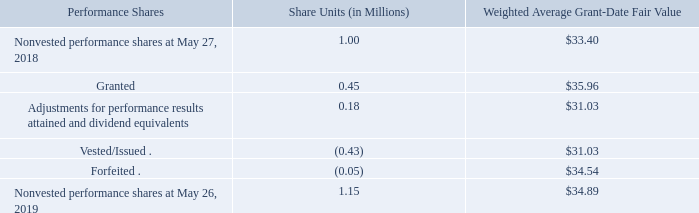Performance Share Awards
In accordance with stockholder-approved equity incentive plans, we grant performance shares to selected executives and other key employees with vesting contingent upon meeting various Company-wide performance goals. The performance goal for one-third of the target number of performance shares for the three-year performance period ending in fiscal 2019 (the "2019 performance period") is based on our fiscal 2017 EBITDA return on capital, subject to certain adjustments. The fiscal 2017 EBITDA return on capital target, when set, excluded the results of Lamb Weston. The performance goal for the final two-thirds of the target number of performance shares granted for the 2019 performance period is based on our diluted EPS compound annual growth rate ("CAGR"), subject to certain adjustments, measured over the two-year period ending in fiscal 2019. In addition, for certain participants, all performance shares for the 2019 performance period are subject to an overarching EPS goal that must be met in each fiscal year of the 2019 performance period before any payout on the performance shares can be made to such participants. The awards actually earned for the 2019 performance period will range from zero to two hundred percent of the targeted number of performance shares for that period.
The performance goal for each of the three-year performance period ending in fiscal 2020 (the "2020 performance period") and the three-year performance period ending in 2021 ("2021 performance period") is based on our diluted EPS CAGR, subject to certain adjustments, measured over the defined performance period. In addition, for certain participants, all performance shares for the 2020 performance period are subject to an overarching EPS goal that must be met in each fiscal year of the 2020 performance period before any payout on the performance shares can be made to such participants. For each of the 2020 performance period and the 2021 performance period, the awards actually earned will range from zero to two hundred percent of the targeted number of performance shares for such performance period.
Awards, if earned, will be paid in shares of our common stock. Subject to limited exceptions set forth in our performance share plan, any shares earned will be distributed after the end of the performance period, and only if the participant continues to be employed with the Company through the date of distribution. For awards where performance against the performance target has not been certified, the value of the performance shares is adjusted based upon the market price of our common stock and current forecasted performance against the performance targets at the end of each reporting period and amortized as compensation expense over the vesting period. Forfeitures are accounted for as they occur.
A summary of the activity for performance share awards as of May 26, 2019 and changes during the fiscal year then ended is presented below:
The compensation expense for our performance share awards totaled $8.2 million, $11.8 million, and $13.3 million for fiscal 2019, 2018, and 2017, respectively. The tax benefit related to the compensation expense for fiscal 2019, 2018, and 2017 was $2.1 million, $3.9 million, and $5.1 million, respectively.
The total intrinsic value of performance shares vested (including shares paid in lieu of dividends) during fiscal 2019, 2018, and 2017 was $15.7 million, $11.2 million, and $2.8 million, respectively.
Based on estimates at May 26, 2019, we had $13.2 million of total unrecognized compensation expense related to performance shares that will be recognized over a weighted average period of 1.7 years.
What were the total compensation expenses for performance share awards during fiscal 2017 and 2018, respectively? $13.3 million, $11.8 million. How much was the total unrecognized compensation expense related to performance shares? $13.2 million. How many share units that are nonvested performance shares on May 27, 2018?
Answer scale should be: million. 1.00. What is the total price of performance shares that were granted or being adjusted for performance results attained and dividend equivalents?
Answer scale should be: million. (0.45*35.96)+(0.18*31.03) 
Answer: 21.77. What is the ratio of granted share units to forfeited share units? 0.45/0.05 
Answer: 9. What is the ratio of the total price of nonvested performance shares to the total intrinsic value of vested performance shares during 2019?  (1.15*34.89)/15.7 
Answer: 2.56. 